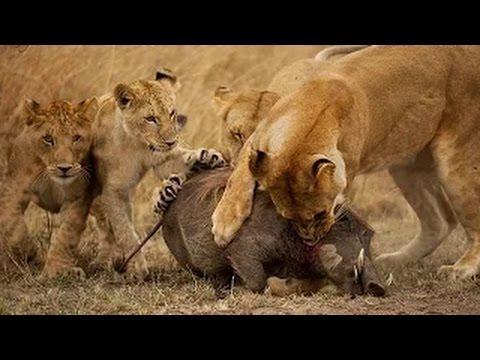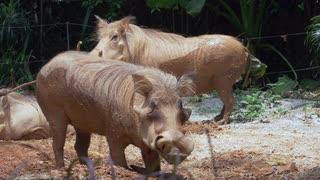The first image is the image on the left, the second image is the image on the right. Examine the images to the left and right. Is the description "there is only one adult animal in the image on the left" accurate? Answer yes or no. No. 